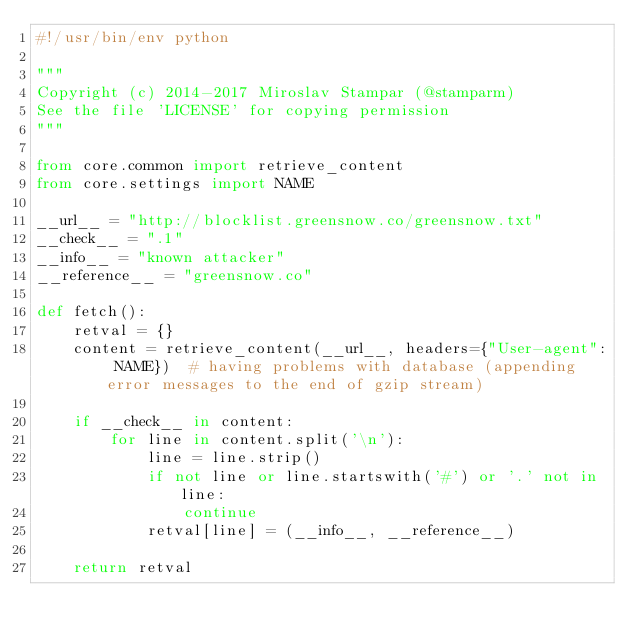Convert code to text. <code><loc_0><loc_0><loc_500><loc_500><_Python_>#!/usr/bin/env python

"""
Copyright (c) 2014-2017 Miroslav Stampar (@stamparm)
See the file 'LICENSE' for copying permission
"""

from core.common import retrieve_content
from core.settings import NAME

__url__ = "http://blocklist.greensnow.co/greensnow.txt"
__check__ = ".1"
__info__ = "known attacker"
__reference__ = "greensnow.co"

def fetch():
    retval = {}
    content = retrieve_content(__url__, headers={"User-agent": NAME})  # having problems with database (appending error messages to the end of gzip stream)

    if __check__ in content:
        for line in content.split('\n'):
            line = line.strip()
            if not line or line.startswith('#') or '.' not in line:
                continue
            retval[line] = (__info__, __reference__)

    return retval
</code> 